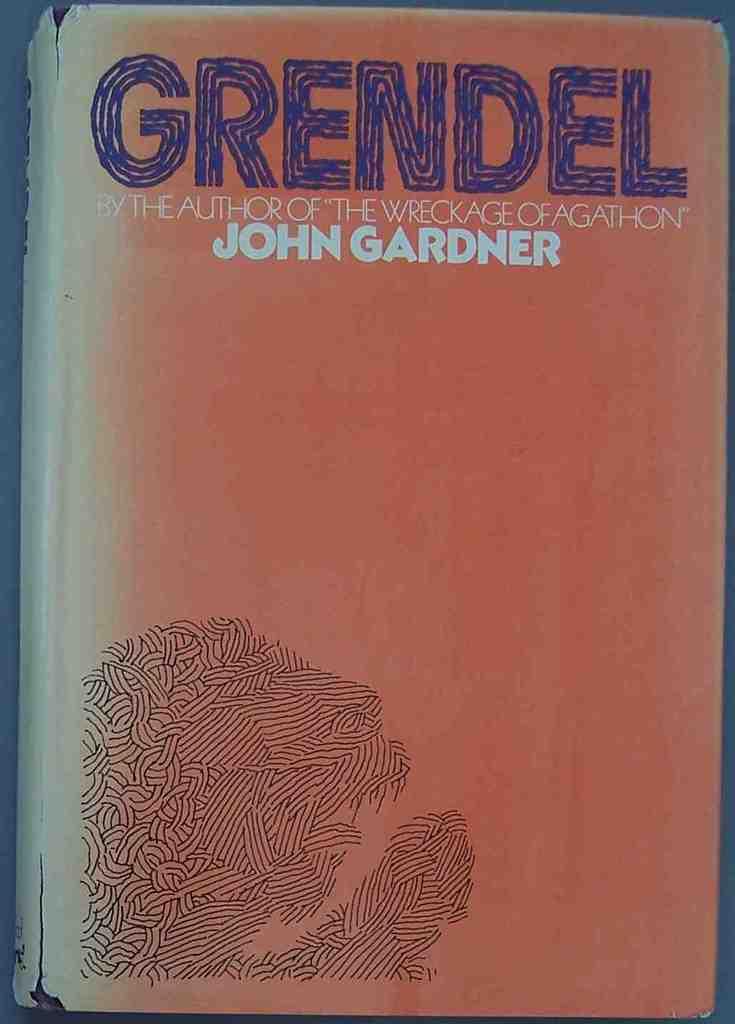What other book did he write?
Ensure brevity in your answer.  The wreckage of agathon. 